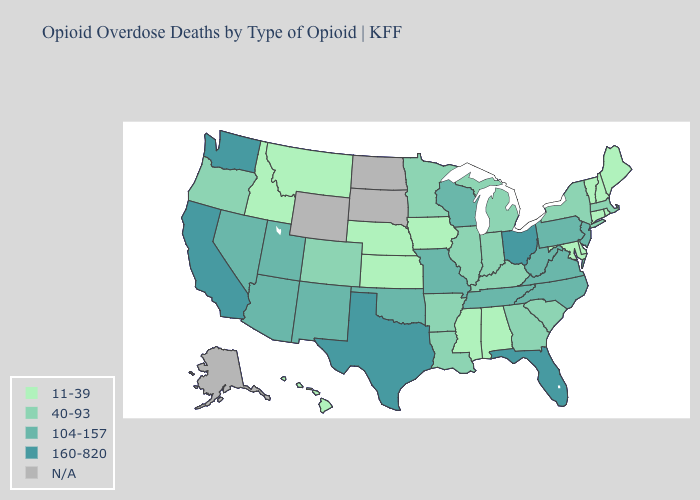Is the legend a continuous bar?
Quick response, please. No. What is the lowest value in states that border Delaware?
Quick response, please. 11-39. Which states have the lowest value in the USA?
Concise answer only. Alabama, Connecticut, Delaware, Hawaii, Idaho, Iowa, Kansas, Maine, Maryland, Mississippi, Montana, Nebraska, New Hampshire, Rhode Island, Vermont. What is the lowest value in the Northeast?
Quick response, please. 11-39. What is the value of Wyoming?
Concise answer only. N/A. What is the value of Missouri?
Answer briefly. 104-157. Does Illinois have the highest value in the USA?
Concise answer only. No. What is the value of Kentucky?
Keep it brief. 40-93. Name the states that have a value in the range N/A?
Be succinct. Alaska, North Dakota, South Dakota, Wyoming. Which states have the highest value in the USA?
Short answer required. California, Florida, Ohio, Texas, Washington. What is the lowest value in the MidWest?
Write a very short answer. 11-39. Name the states that have a value in the range 104-157?
Concise answer only. Arizona, Missouri, Nevada, New Jersey, New Mexico, North Carolina, Oklahoma, Pennsylvania, Tennessee, Utah, Virginia, West Virginia, Wisconsin. Which states have the highest value in the USA?
Give a very brief answer. California, Florida, Ohio, Texas, Washington. Name the states that have a value in the range N/A?
Quick response, please. Alaska, North Dakota, South Dakota, Wyoming. What is the highest value in states that border Illinois?
Concise answer only. 104-157. 